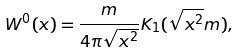Convert formula to latex. <formula><loc_0><loc_0><loc_500><loc_500>W ^ { 0 } ( x ) = \frac { m } { 4 \pi \sqrt { x ^ { 2 } } } K _ { 1 } ( \sqrt { x ^ { 2 } } m ) ,</formula> 